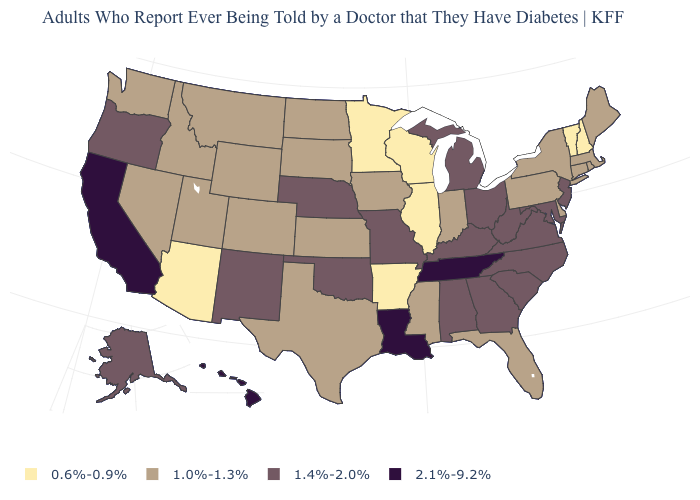What is the value of Connecticut?
Quick response, please. 1.0%-1.3%. Does the first symbol in the legend represent the smallest category?
Concise answer only. Yes. What is the value of New Jersey?
Quick response, please. 1.4%-2.0%. Does the map have missing data?
Keep it brief. No. What is the value of Indiana?
Short answer required. 1.0%-1.3%. What is the highest value in the Northeast ?
Be succinct. 1.4%-2.0%. What is the value of New York?
Write a very short answer. 1.0%-1.3%. Does New Jersey have the highest value in the Northeast?
Quick response, please. Yes. What is the value of Mississippi?
Concise answer only. 1.0%-1.3%. What is the value of South Dakota?
Keep it brief. 1.0%-1.3%. What is the lowest value in the USA?
Be succinct. 0.6%-0.9%. What is the lowest value in states that border Oregon?
Short answer required. 1.0%-1.3%. Which states hav the highest value in the MidWest?
Give a very brief answer. Michigan, Missouri, Nebraska, Ohio. Does the map have missing data?
Quick response, please. No. 